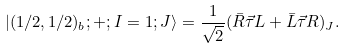Convert formula to latex. <formula><loc_0><loc_0><loc_500><loc_500>| ( 1 / 2 , 1 / 2 ) _ { b } ; + ; I = 1 ; J \rangle = \frac { 1 } { \sqrt { 2 } } ( \bar { R } \vec { \tau } L + \bar { L } \vec { \tau } R ) _ { J } .</formula> 